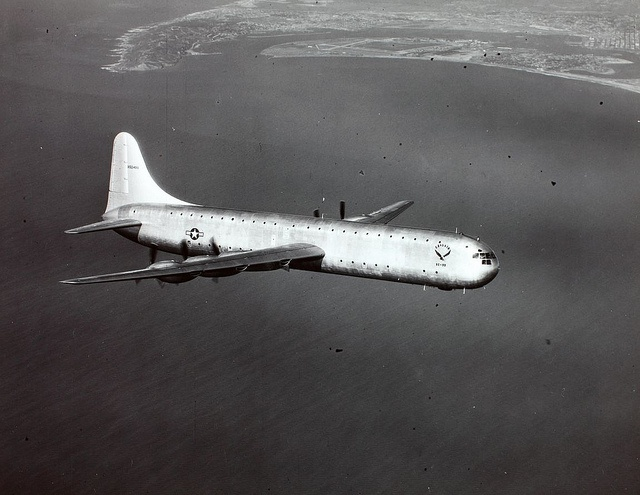Describe the objects in this image and their specific colors. I can see a airplane in gray, lightgray, black, and darkgray tones in this image. 